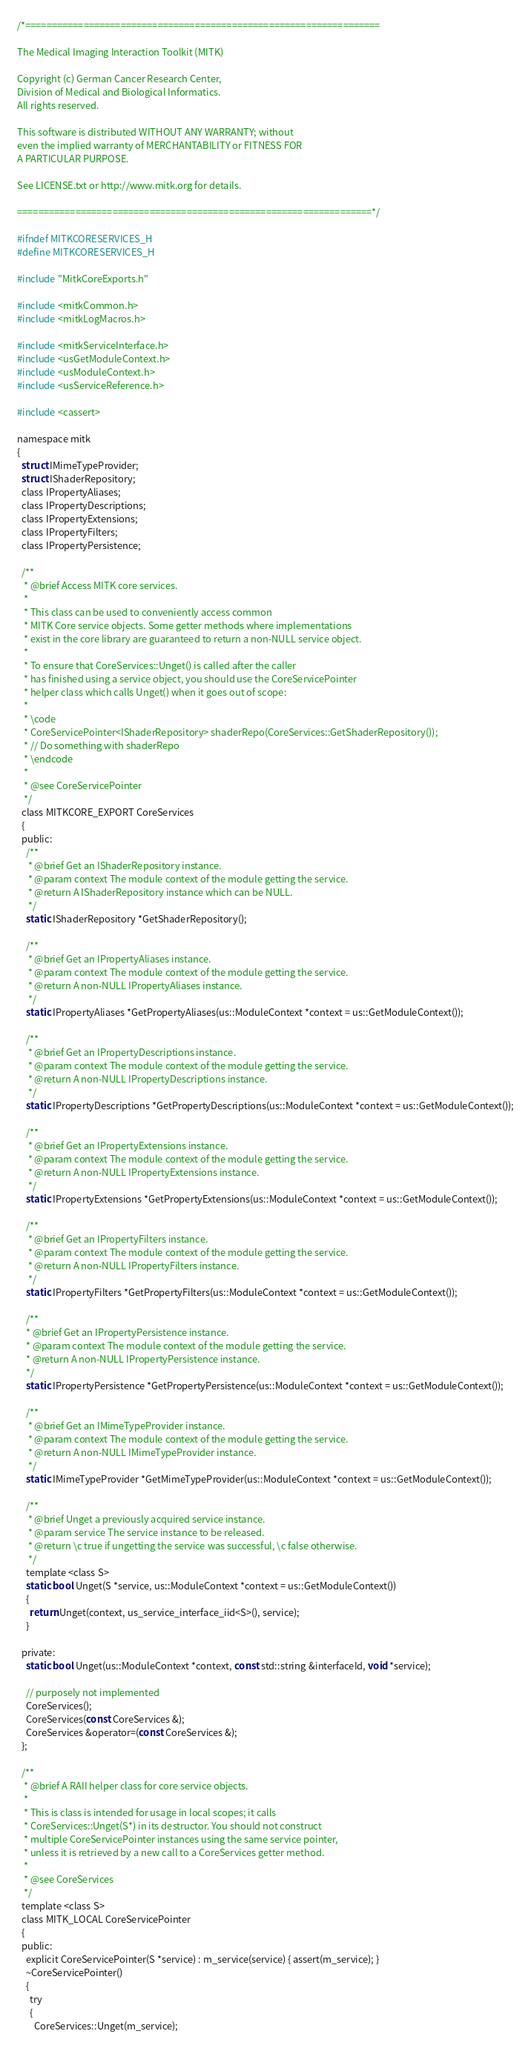Convert code to text. <code><loc_0><loc_0><loc_500><loc_500><_C_>/*===================================================================

The Medical Imaging Interaction Toolkit (MITK)

Copyright (c) German Cancer Research Center,
Division of Medical and Biological Informatics.
All rights reserved.

This software is distributed WITHOUT ANY WARRANTY; without
even the implied warranty of MERCHANTABILITY or FITNESS FOR
A PARTICULAR PURPOSE.

See LICENSE.txt or http://www.mitk.org for details.

===================================================================*/

#ifndef MITKCORESERVICES_H
#define MITKCORESERVICES_H

#include "MitkCoreExports.h"

#include <mitkCommon.h>
#include <mitkLogMacros.h>

#include <mitkServiceInterface.h>
#include <usGetModuleContext.h>
#include <usModuleContext.h>
#include <usServiceReference.h>

#include <cassert>

namespace mitk
{
  struct IMimeTypeProvider;
  struct IShaderRepository;
  class IPropertyAliases;
  class IPropertyDescriptions;
  class IPropertyExtensions;
  class IPropertyFilters;
  class IPropertyPersistence;

  /**
   * @brief Access MITK core services.
   *
   * This class can be used to conveniently access common
   * MITK Core service objects. Some getter methods where implementations
   * exist in the core library are guaranteed to return a non-NULL service object.
   *
   * To ensure that CoreServices::Unget() is called after the caller
   * has finished using a service object, you should use the CoreServicePointer
   * helper class which calls Unget() when it goes out of scope:
   *
   * \code
   * CoreServicePointer<IShaderRepository> shaderRepo(CoreServices::GetShaderRepository());
   * // Do something with shaderRepo
   * \endcode
   *
   * @see CoreServicePointer
   */
  class MITKCORE_EXPORT CoreServices
  {
  public:
    /**
     * @brief Get an IShaderRepository instance.
     * @param context The module context of the module getting the service.
     * @return A IShaderRepository instance which can be NULL.
     */
    static IShaderRepository *GetShaderRepository();

    /**
     * @brief Get an IPropertyAliases instance.
     * @param context The module context of the module getting the service.
     * @return A non-NULL IPropertyAliases instance.
     */
    static IPropertyAliases *GetPropertyAliases(us::ModuleContext *context = us::GetModuleContext());

    /**
     * @brief Get an IPropertyDescriptions instance.
     * @param context The module context of the module getting the service.
     * @return A non-NULL IPropertyDescriptions instance.
     */
    static IPropertyDescriptions *GetPropertyDescriptions(us::ModuleContext *context = us::GetModuleContext());

    /**
     * @brief Get an IPropertyExtensions instance.
     * @param context The module context of the module getting the service.
     * @return A non-NULL IPropertyExtensions instance.
     */
    static IPropertyExtensions *GetPropertyExtensions(us::ModuleContext *context = us::GetModuleContext());

    /**
     * @brief Get an IPropertyFilters instance.
     * @param context The module context of the module getting the service.
     * @return A non-NULL IPropertyFilters instance.
     */
    static IPropertyFilters *GetPropertyFilters(us::ModuleContext *context = us::GetModuleContext());

    /**
    * @brief Get an IPropertyPersistence instance.
    * @param context The module context of the module getting the service.
    * @return A non-NULL IPropertyPersistence instance.
    */
    static IPropertyPersistence *GetPropertyPersistence(us::ModuleContext *context = us::GetModuleContext());

    /**
     * @brief Get an IMimeTypeProvider instance.
     * @param context The module context of the module getting the service.
     * @return A non-NULL IMimeTypeProvider instance.
     */
    static IMimeTypeProvider *GetMimeTypeProvider(us::ModuleContext *context = us::GetModuleContext());

    /**
     * @brief Unget a previously acquired service instance.
     * @param service The service instance to be released.
     * @return \c true if ungetting the service was successful, \c false otherwise.
     */
    template <class S>
    static bool Unget(S *service, us::ModuleContext *context = us::GetModuleContext())
    {
      return Unget(context, us_service_interface_iid<S>(), service);
    }

  private:
    static bool Unget(us::ModuleContext *context, const std::string &interfaceId, void *service);

    // purposely not implemented
    CoreServices();
    CoreServices(const CoreServices &);
    CoreServices &operator=(const CoreServices &);
  };

  /**
   * @brief A RAII helper class for core service objects.
   *
   * This is class is intended for usage in local scopes; it calls
   * CoreServices::Unget(S*) in its destructor. You should not construct
   * multiple CoreServicePointer instances using the same service pointer,
   * unless it is retrieved by a new call to a CoreServices getter method.
   *
   * @see CoreServices
   */
  template <class S>
  class MITK_LOCAL CoreServicePointer
  {
  public:
    explicit CoreServicePointer(S *service) : m_service(service) { assert(m_service); }
    ~CoreServicePointer()
    {
      try
      {
        CoreServices::Unget(m_service);</code> 